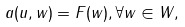<formula> <loc_0><loc_0><loc_500><loc_500>a ( u , w ) = F ( w ) , \forall w \in W ,</formula> 